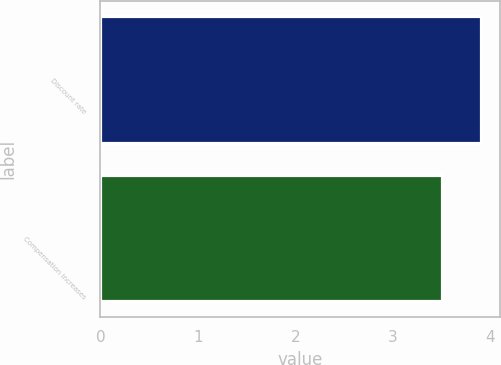Convert chart. <chart><loc_0><loc_0><loc_500><loc_500><bar_chart><fcel>Discount rate<fcel>Compensation increases<nl><fcel>3.9<fcel>3.5<nl></chart> 